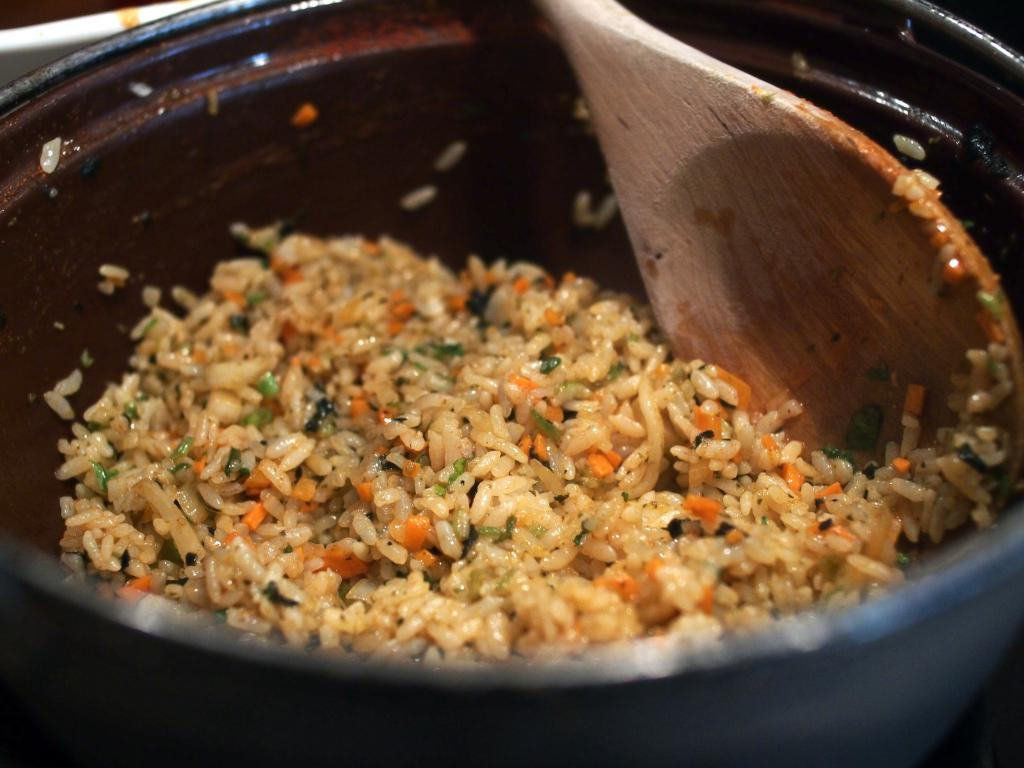What is the main subject of the image? There is a food item in the image. What is the color of the bowl containing the food item? The food item is in a black color bowl. What utensil is present in the image? There is a wooden spatula in the image. What type of note is attached to the doll in the image? There is no doll or note present in the image; it only features a food item in a black color bowl and a wooden spatula. 